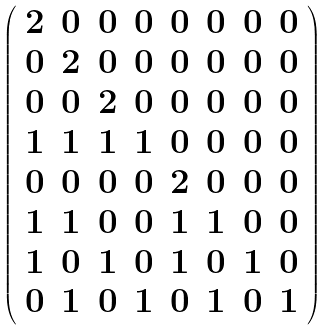Convert formula to latex. <formula><loc_0><loc_0><loc_500><loc_500>\left ( \begin{array} { c c c c c c c c } 2 & 0 & 0 & 0 & 0 & 0 & 0 & 0 \\ 0 & 2 & 0 & 0 & 0 & 0 & 0 & 0 \\ 0 & 0 & 2 & 0 & 0 & 0 & 0 & 0 \\ 1 & 1 & 1 & 1 & 0 & 0 & 0 & 0 \\ 0 & 0 & 0 & 0 & 2 & 0 & 0 & 0 \\ 1 & 1 & 0 & 0 & 1 & 1 & 0 & 0 \\ 1 & 0 & 1 & 0 & 1 & 0 & 1 & 0 \\ 0 & 1 & 0 & 1 & 0 & 1 & 0 & 1 \end{array} \right )</formula> 